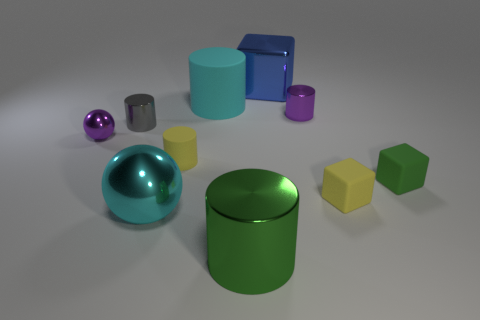If you had to guess, what could be the purpose of arranging these objects in such a manner? This arrangement may serve multiple purposes. It could represent a deliberate compositional technique in photography to study light, shadow, and reflections. Alternatively, it might be a simple visual aid used in educational contexts to teach shapes, colors, and spatial relationships to students. 